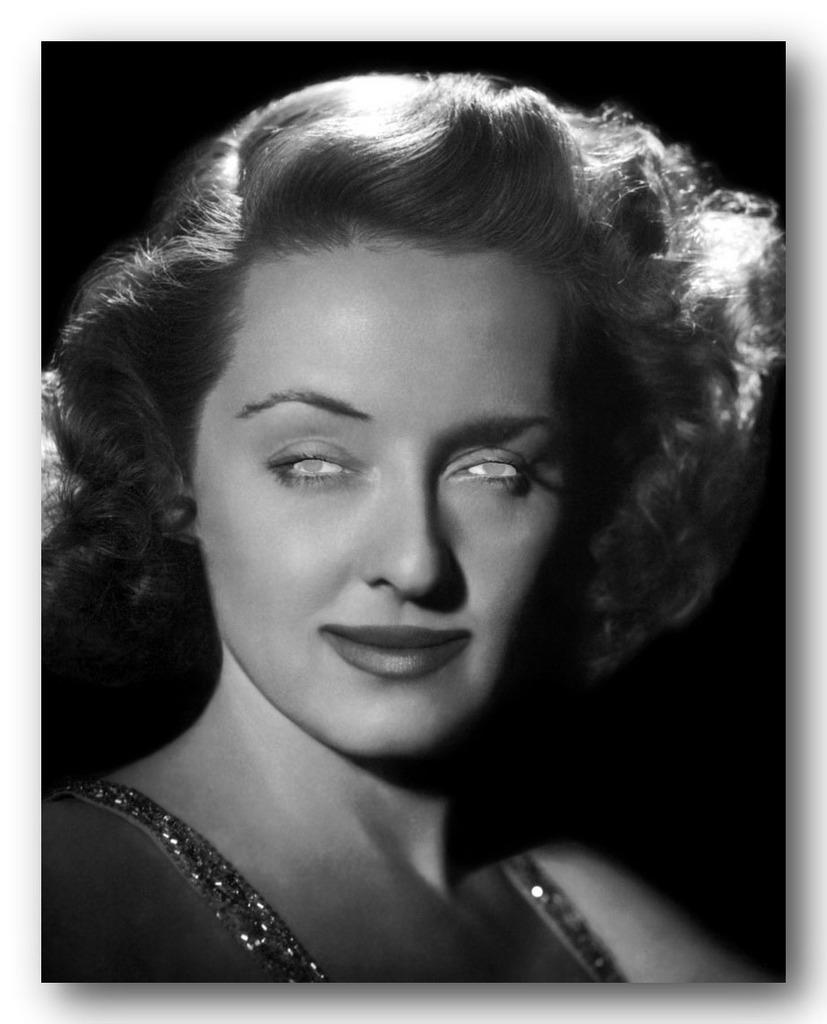How would you summarize this image in a sentence or two? In this black and white image there is a girl. The background is dark. 